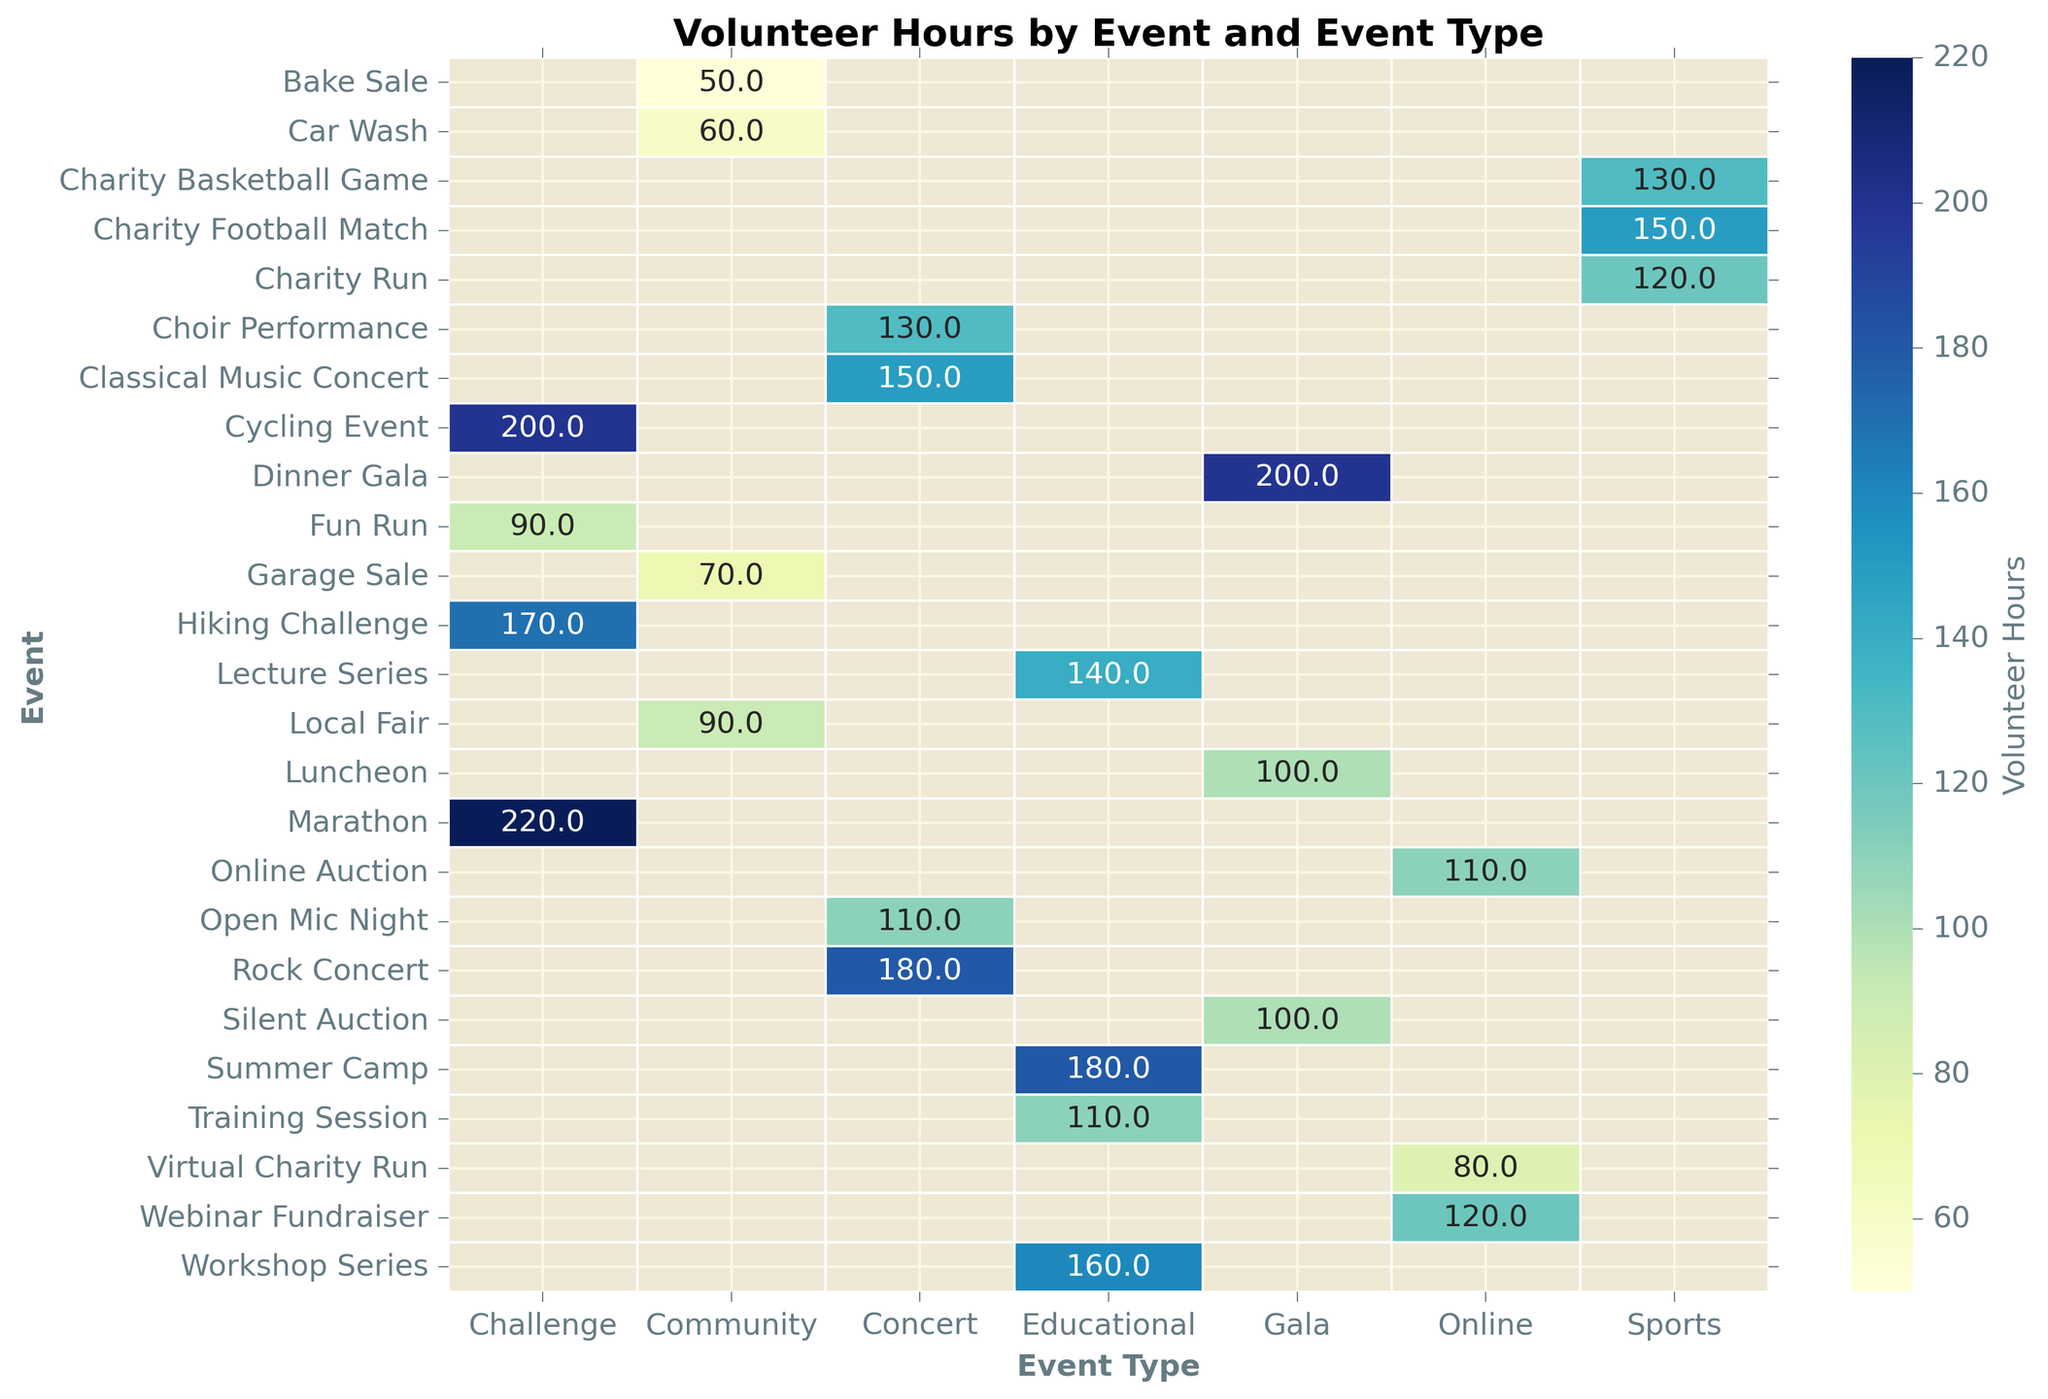What's the event with the highest volunteer hours contribution? By looking at the darkest color on the heatmap in the volunteer hours scale, which represents the highest value, we can see that the event 'Marathon' has the highest number of volunteer hours.
Answer: Marathon How do the volunteer hours for the 'Charity Run' compare to the 'Charity Football Match'? By looking at the heatmap under the "Sports" event type, we can see that 'Charity Run' has 120 volunteer hours and 'Charity Football Match' has 150 volunteer hours. Therefore, 'Charity Football Match' has more volunteer hours.
Answer: Charity Football Match has more Which type of event generally sees more volunteer hours contributed? By evaluating the shades representing volunteer hours for each event type, we can see that the "Challenge" event type has several bars with higher values, indicating that it generally sees more volunteer hours.
Answer: Challenge What's the average number of volunteer hours for 'Concert' type events? By summing the volunteer hours for 'Concert' events: (180 + 130 + 150 + 110) = 570, and dividing by the number of events (4), the average is 570/4 = 142.5 volunteer hours.
Answer: 142.5 Which event type has the least volunteer hours contributed for any single event, and what is that event? By finding the lightest color bar in the heatmap, it can be seen that the 'Bake Sale' in the 'Community' event type has the least volunteer hours of 50.
Answer: Community, Bake Sale Which has more volunteer hours, 'Dinner Gala' or 'Silent Auction'? By examining the heatmap under the "Gala" event type, 'Dinner Gala' has 200 volunteer hours, while 'Silent Auction' has 100 volunteer hours. Thus, 'Dinner Gala' has more volunteer hours.
Answer: Dinner Gala Are there any events with equal volunteer hours? If so, which ones? By checking for identical values across the heatmap, it can be seen that both 'Silent Auction' under Gala and 'Luncheon' under Gala have 100 volunteer hours.
Answer: Silent Auction and Luncheon How does the total volunteer hours for 'Community' events compare to 'Sports' events? Summing up the volunteer hours for 'Community' events: (90 + 50 + 60 + 70) = 270, and for 'Sports' events: (120 + 150 + 130) = 400. Thus, 'Sports' events have more total volunteer hours.
Answer: Sports have more Looking at 'Online' events, which one has the most volunteer hours? Referring to the heatmap under the "Online" event type, the 'Webinar Fundraiser' shows the highest number of volunteer hours at 120.
Answer: Webinar Fundraiser 